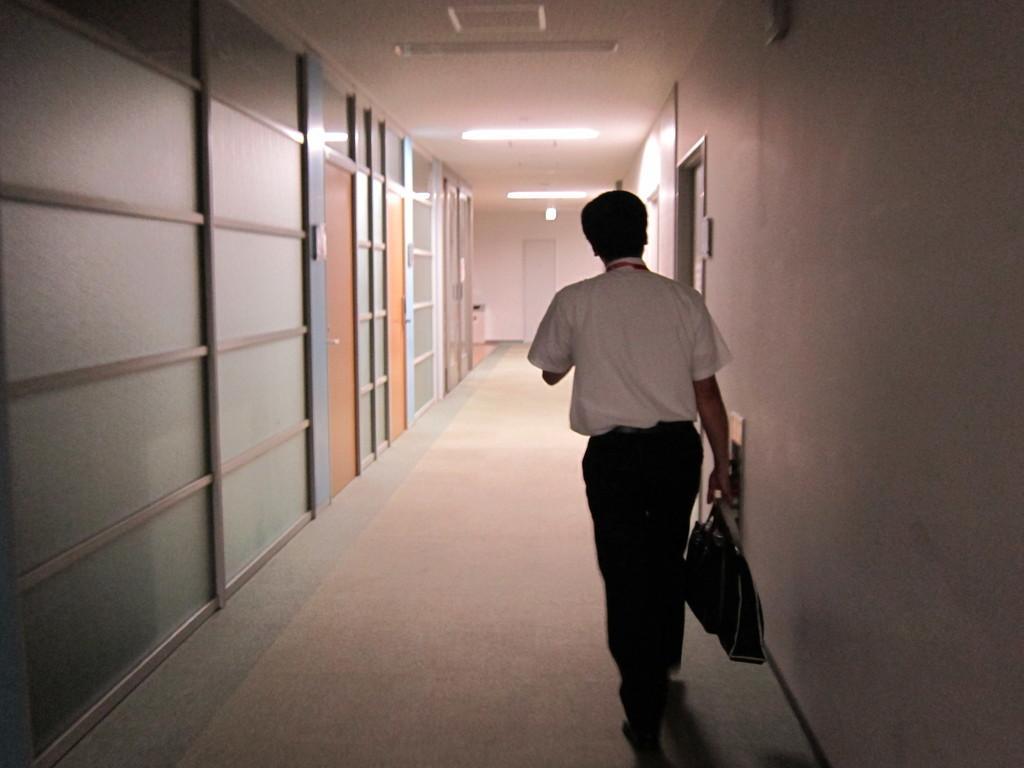Please provide a concise description of this image. This image is taken indoors. At the bottom of the image there is a floor. At the top of the image there is a ceiling with lights. On the right side of the image there is a wall with doors and a man is walking on the floor and he is holding a bag in his hand. On the left side of the image there is a wall with doors. 